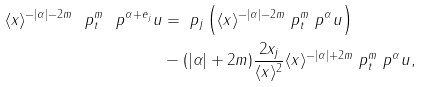Convert formula to latex. <formula><loc_0><loc_0><loc_500><loc_500>\langle { x } \rangle ^ { - | \alpha | - 2 m } \ p _ { t } ^ { m } \ p ^ { \alpha + e _ { j } } u & = \ p _ { j } \left ( \langle { x } \rangle ^ { - | \alpha | - 2 m } \ p _ { t } ^ { m } \ p ^ { \alpha } u \right ) \\ & - ( | \alpha | + 2 m ) \frac { 2 x _ { j } } { \langle { x } \rangle ^ { 2 } } \langle { x } \rangle ^ { - | \alpha | + 2 m } \ p _ { t } ^ { m } \ p ^ { \alpha } { u } ,</formula> 